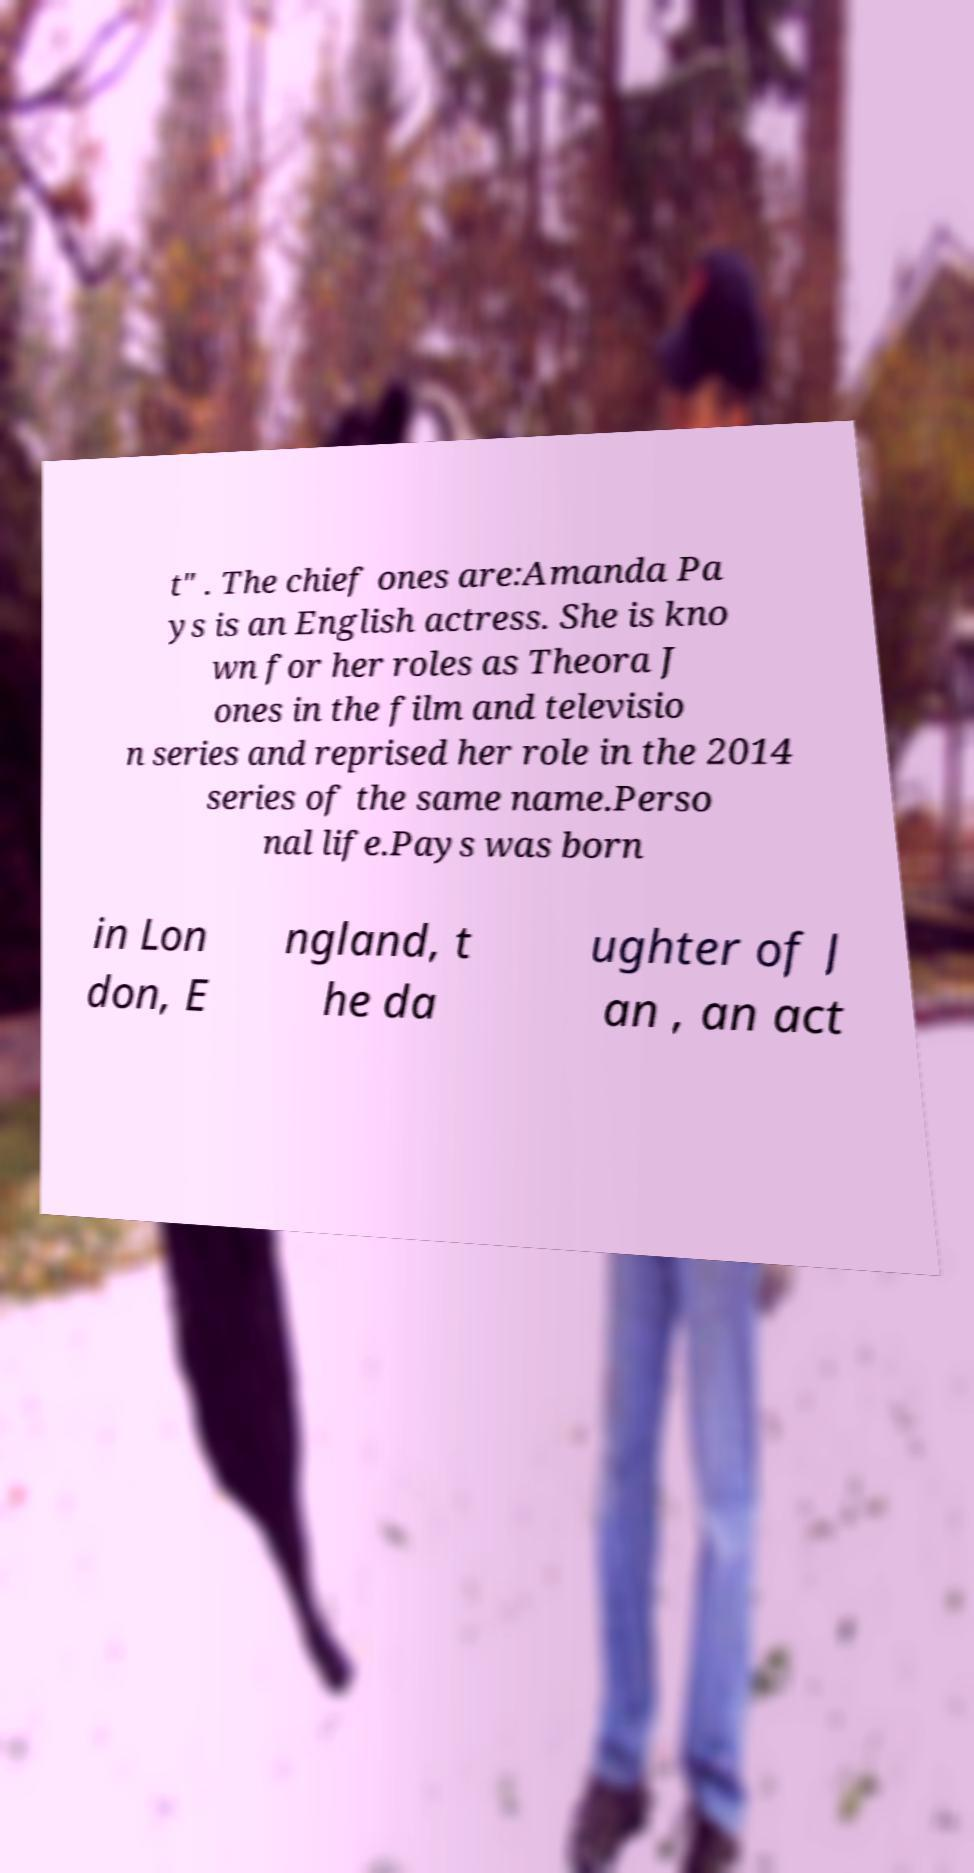Could you assist in decoding the text presented in this image and type it out clearly? t" . The chief ones are:Amanda Pa ys is an English actress. She is kno wn for her roles as Theora J ones in the film and televisio n series and reprised her role in the 2014 series of the same name.Perso nal life.Pays was born in Lon don, E ngland, t he da ughter of J an , an act 